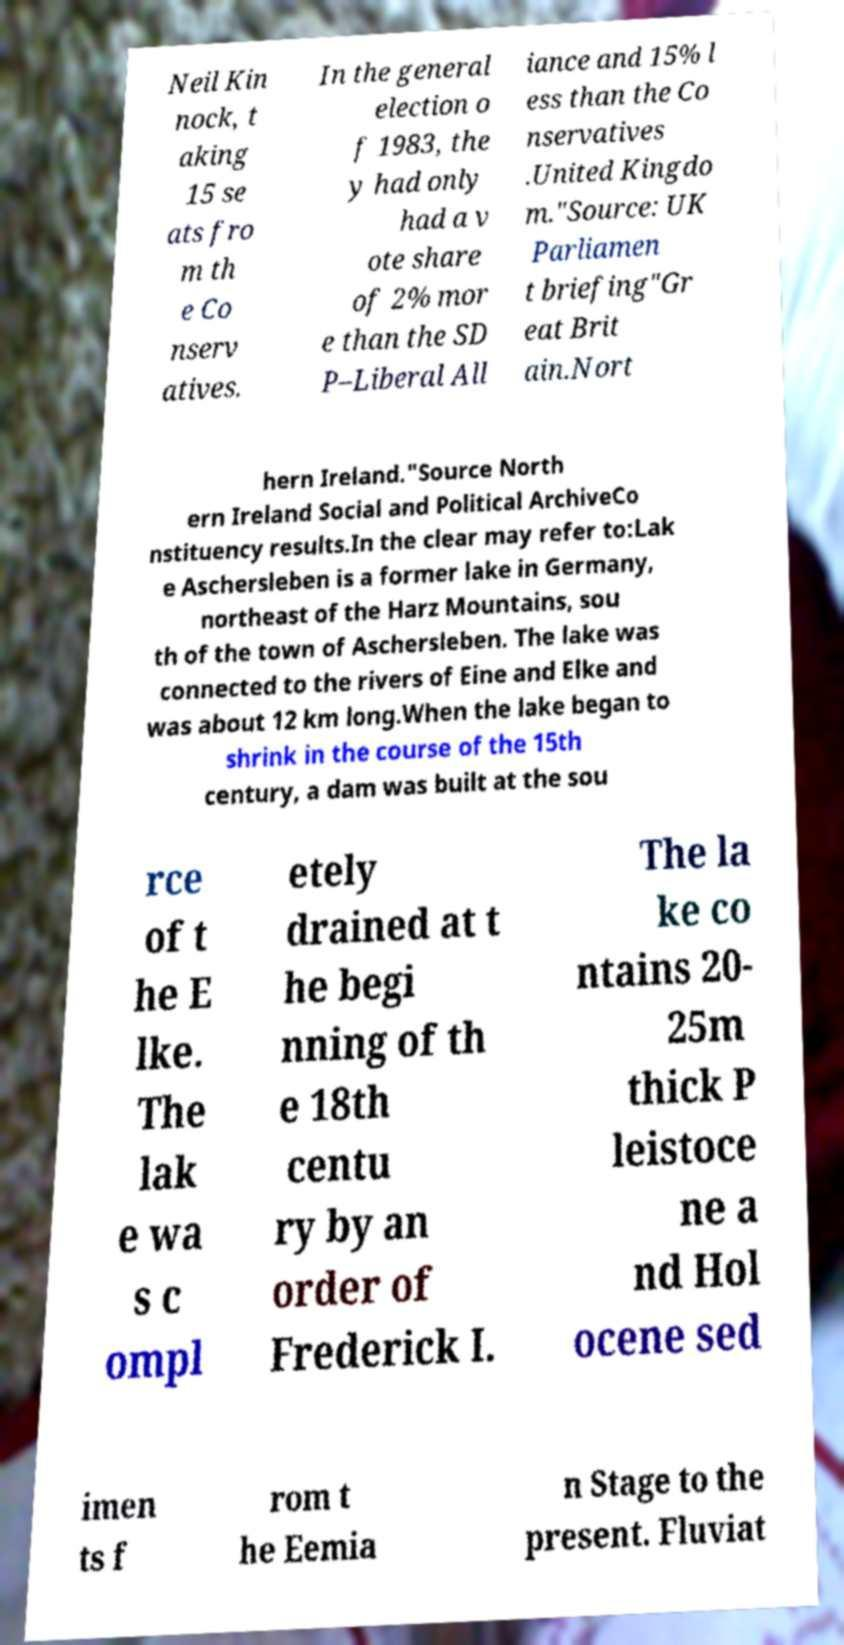For documentation purposes, I need the text within this image transcribed. Could you provide that? Neil Kin nock, t aking 15 se ats fro m th e Co nserv atives. In the general election o f 1983, the y had only had a v ote share of 2% mor e than the SD P–Liberal All iance and 15% l ess than the Co nservatives .United Kingdo m."Source: UK Parliamen t briefing"Gr eat Brit ain.Nort hern Ireland."Source North ern Ireland Social and Political ArchiveCo nstituency results.In the clear may refer to:Lak e Aschersleben is a former lake in Germany, northeast of the Harz Mountains, sou th of the town of Aschersleben. The lake was connected to the rivers of Eine and Elke and was about 12 km long.When the lake began to shrink in the course of the 15th century, a dam was built at the sou rce of t he E lke. The lak e wa s c ompl etely drained at t he begi nning of th e 18th centu ry by an order of Frederick I. The la ke co ntains 20- 25m thick P leistoce ne a nd Hol ocene sed imen ts f rom t he Eemia n Stage to the present. Fluviat 